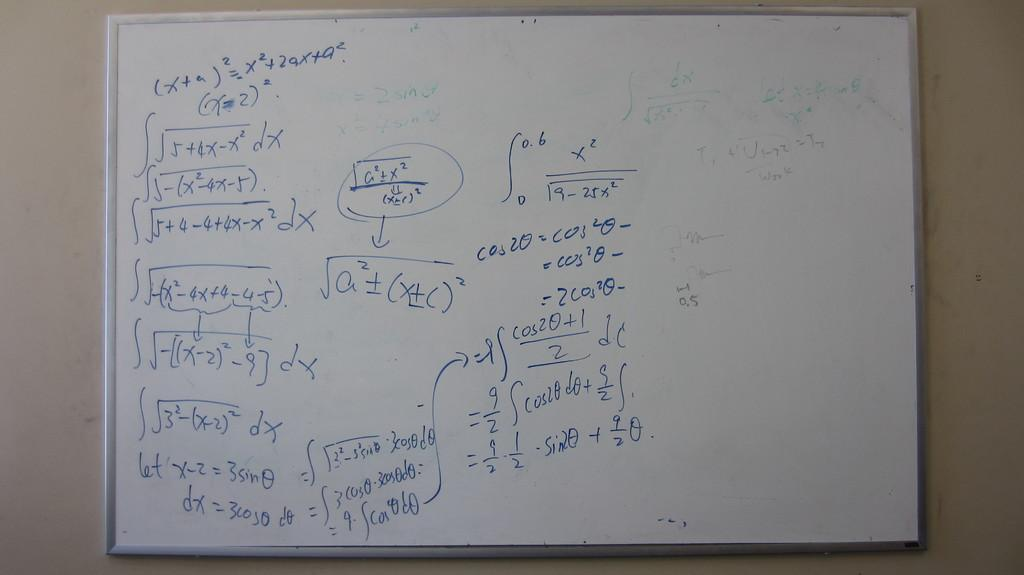Provide a one-sentence caption for the provided image. White board that have equations and arrows with math. 